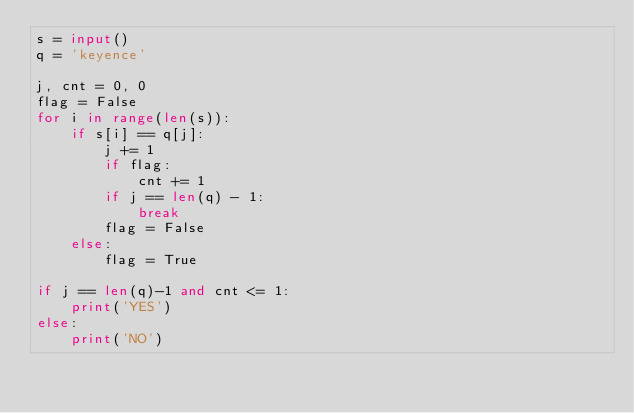Convert code to text. <code><loc_0><loc_0><loc_500><loc_500><_Python_>s = input()
q = 'keyence'

j, cnt = 0, 0
flag = False
for i in range(len(s)):
    if s[i] == q[j]:
        j += 1
        if flag:
            cnt += 1
        if j == len(q) - 1:
            break
        flag = False
    else:
        flag = True

if j == len(q)-1 and cnt <= 1:
    print('YES')
else:
    print('NO')</code> 